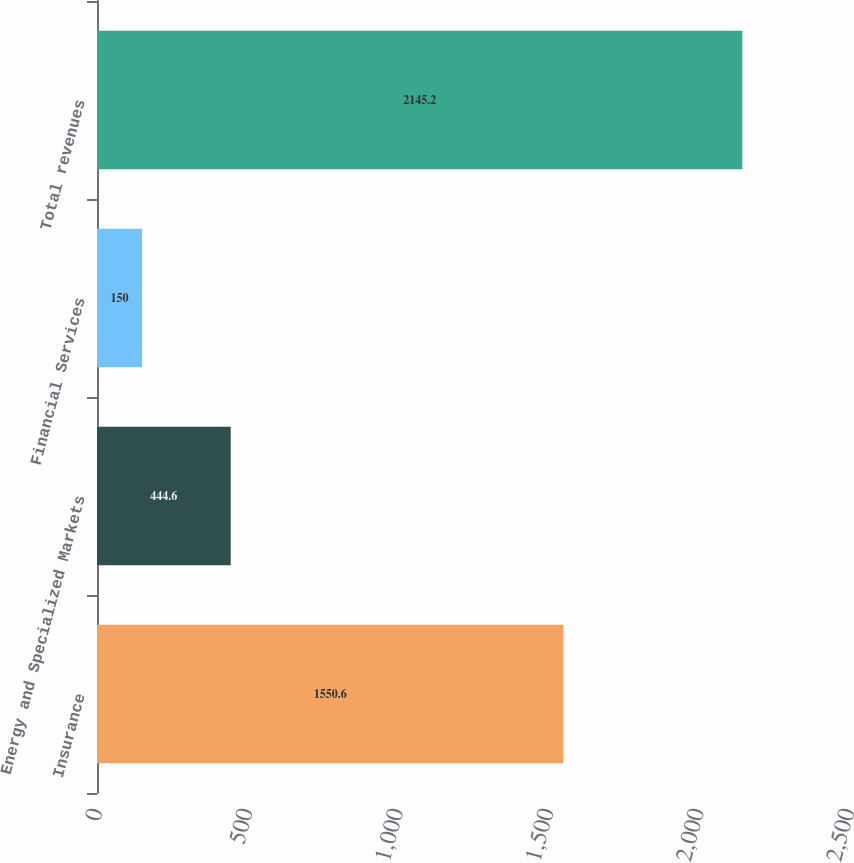Convert chart. <chart><loc_0><loc_0><loc_500><loc_500><bar_chart><fcel>Insurance<fcel>Energy and Specialized Markets<fcel>Financial Services<fcel>Total revenues<nl><fcel>1550.6<fcel>444.6<fcel>150<fcel>2145.2<nl></chart> 